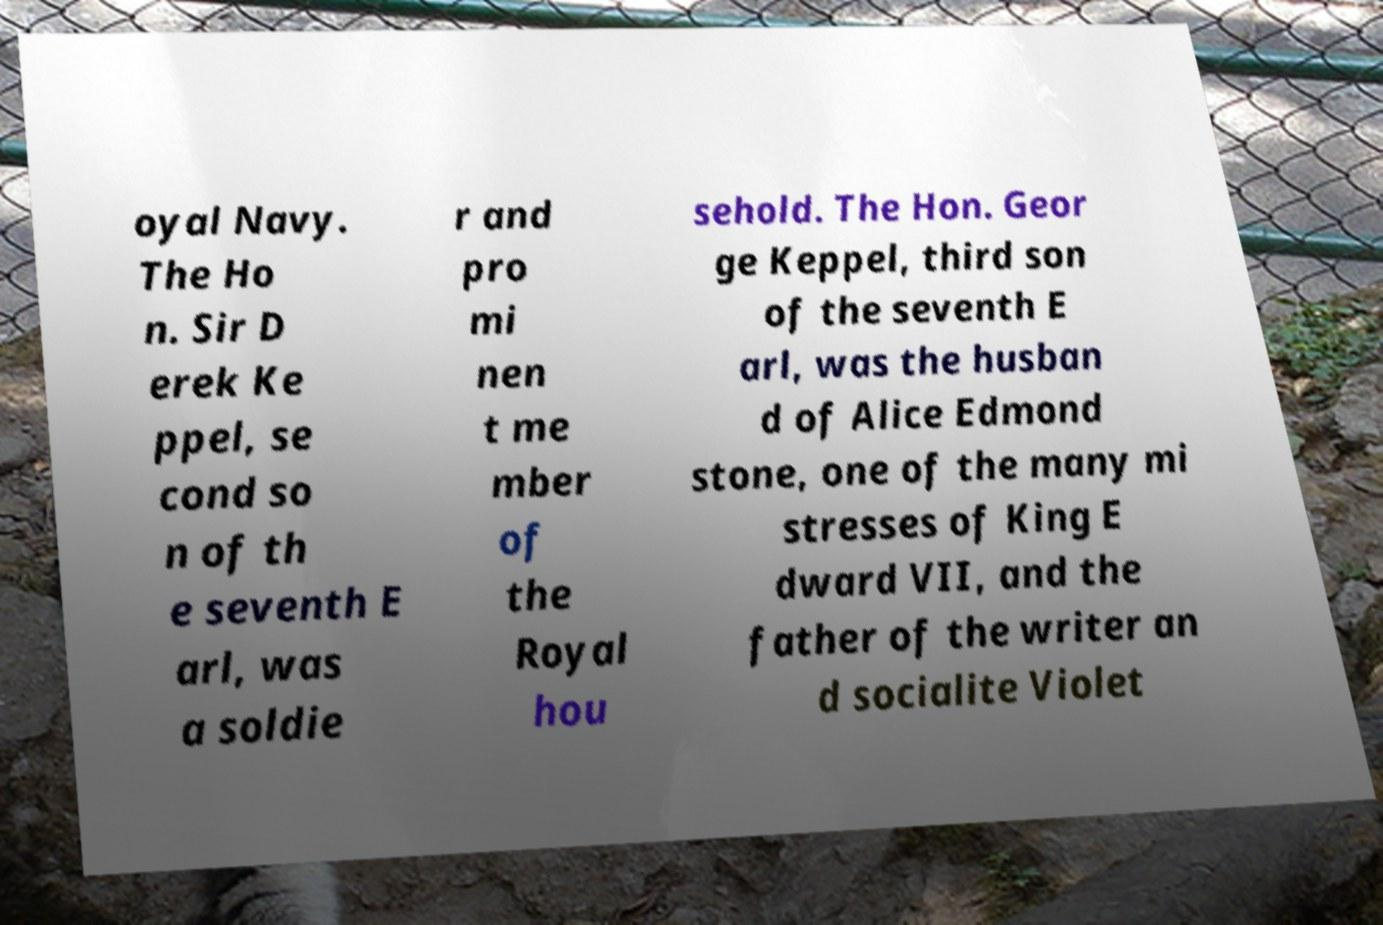For documentation purposes, I need the text within this image transcribed. Could you provide that? oyal Navy. The Ho n. Sir D erek Ke ppel, se cond so n of th e seventh E arl, was a soldie r and pro mi nen t me mber of the Royal hou sehold. The Hon. Geor ge Keppel, third son of the seventh E arl, was the husban d of Alice Edmond stone, one of the many mi stresses of King E dward VII, and the father of the writer an d socialite Violet 